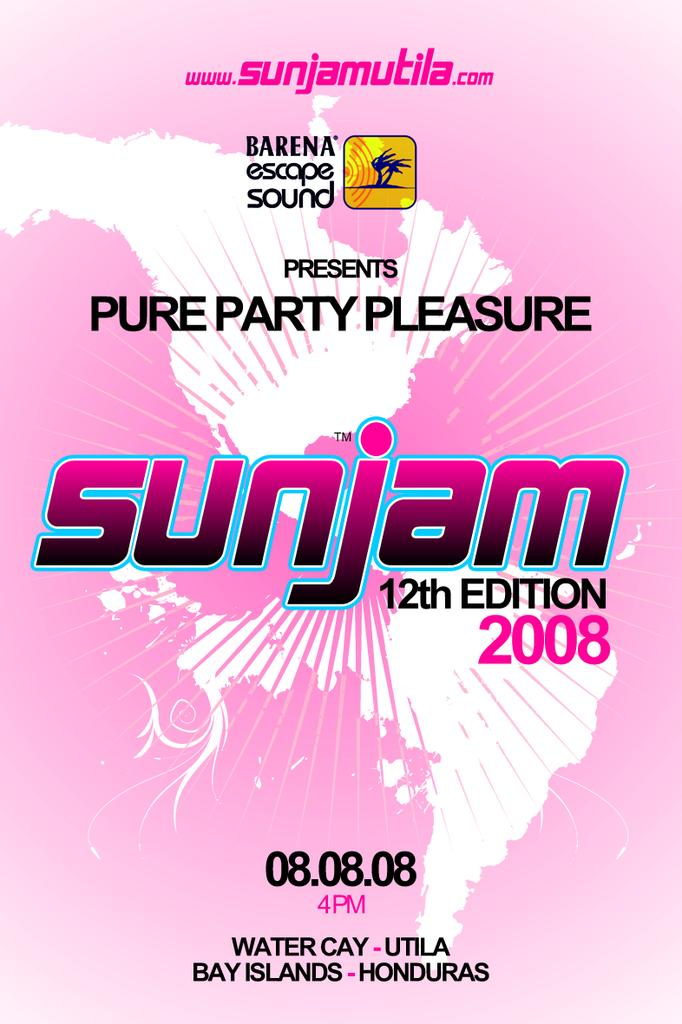<image>
Describe the image concisely. an advertisement for sunjam in the year 2008 